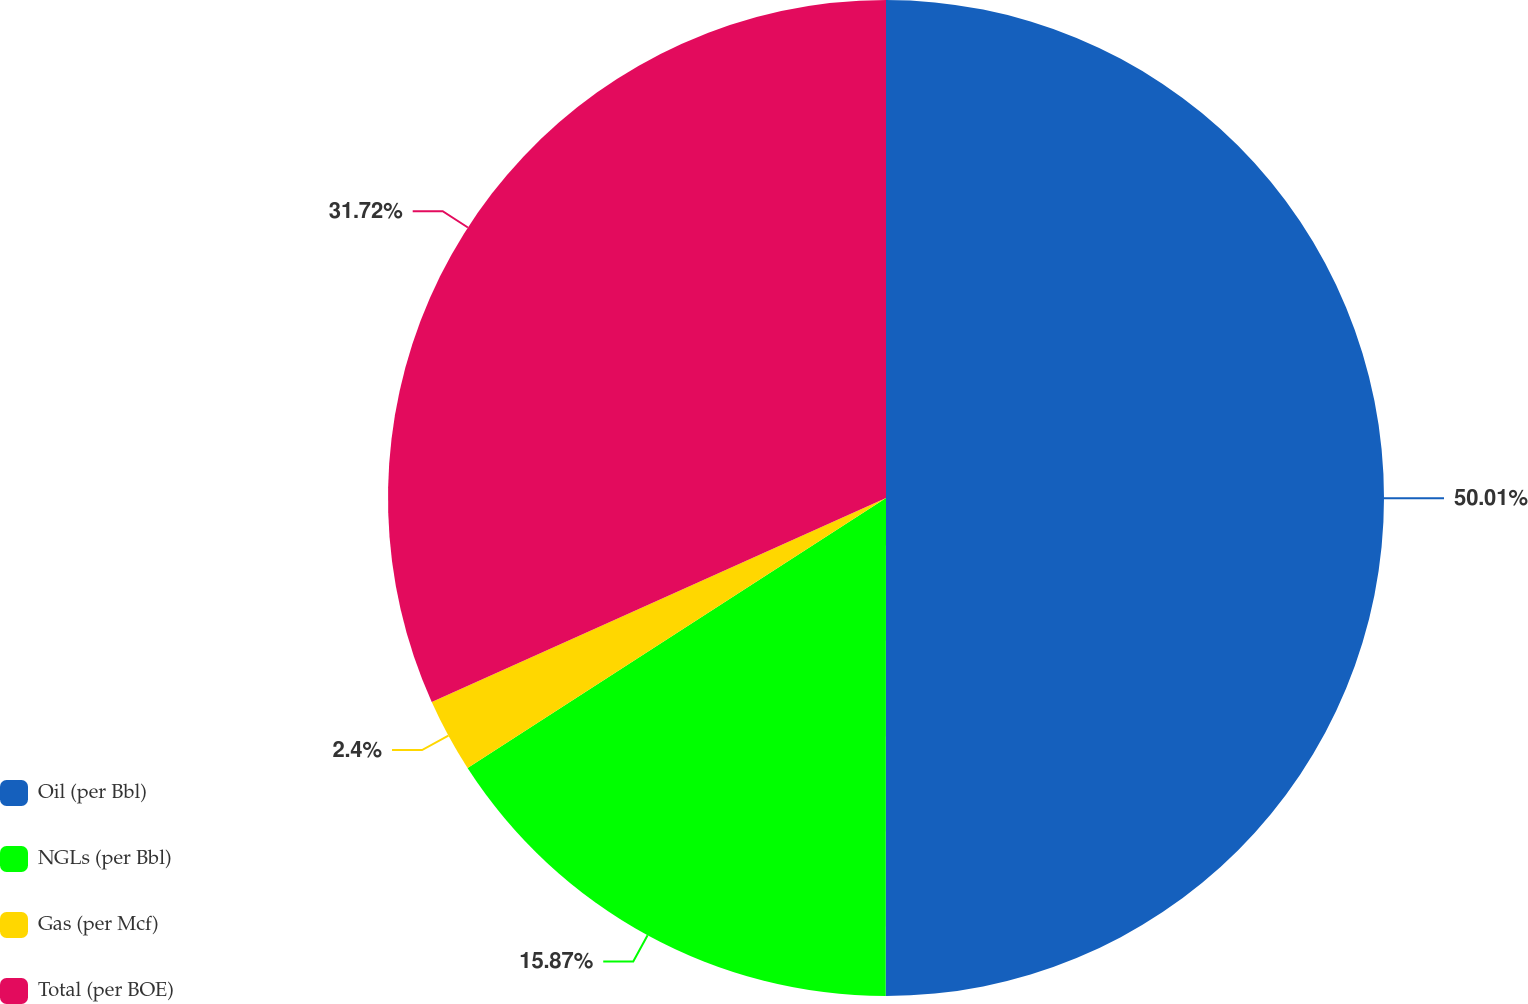<chart> <loc_0><loc_0><loc_500><loc_500><pie_chart><fcel>Oil (per Bbl)<fcel>NGLs (per Bbl)<fcel>Gas (per Mcf)<fcel>Total (per BOE)<nl><fcel>50.01%<fcel>15.87%<fcel>2.4%<fcel>31.72%<nl></chart> 